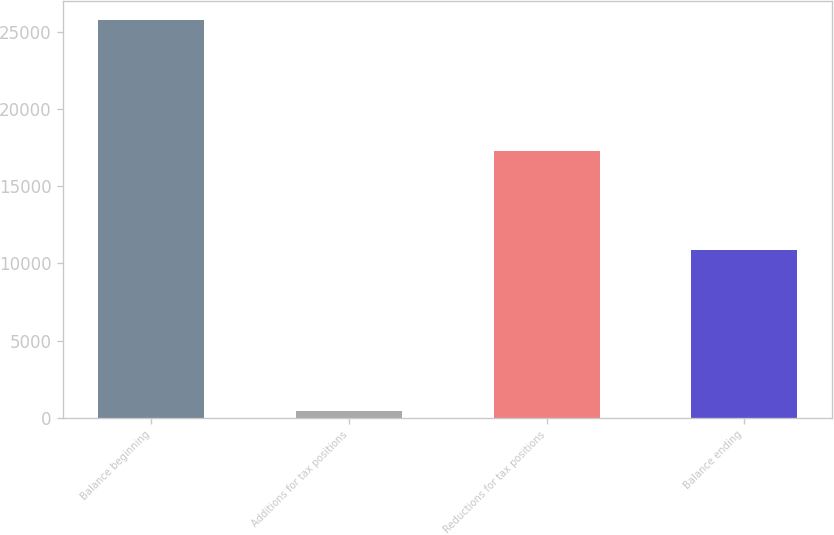<chart> <loc_0><loc_0><loc_500><loc_500><bar_chart><fcel>Balance beginning<fcel>Additions for tax positions<fcel>Reductions for tax positions<fcel>Balance ending<nl><fcel>25744<fcel>463<fcel>17254<fcel>10887<nl></chart> 